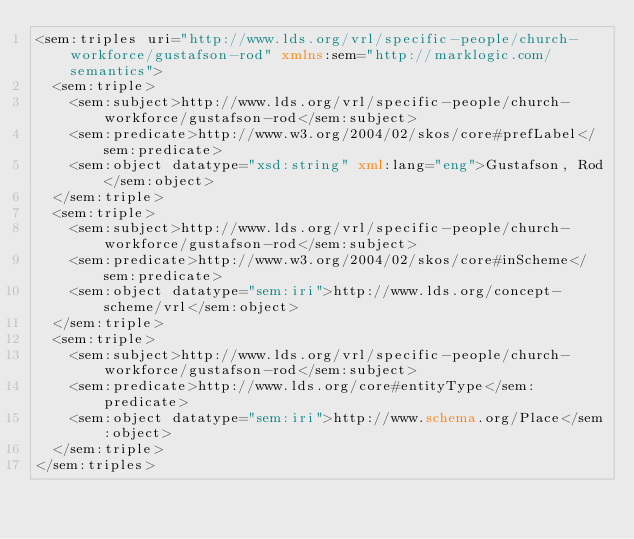Convert code to text. <code><loc_0><loc_0><loc_500><loc_500><_XML_><sem:triples uri="http://www.lds.org/vrl/specific-people/church-workforce/gustafson-rod" xmlns:sem="http://marklogic.com/semantics">
  <sem:triple>
    <sem:subject>http://www.lds.org/vrl/specific-people/church-workforce/gustafson-rod</sem:subject>
    <sem:predicate>http://www.w3.org/2004/02/skos/core#prefLabel</sem:predicate>
    <sem:object datatype="xsd:string" xml:lang="eng">Gustafson, Rod</sem:object>
  </sem:triple>
  <sem:triple>
    <sem:subject>http://www.lds.org/vrl/specific-people/church-workforce/gustafson-rod</sem:subject>
    <sem:predicate>http://www.w3.org/2004/02/skos/core#inScheme</sem:predicate>
    <sem:object datatype="sem:iri">http://www.lds.org/concept-scheme/vrl</sem:object>
  </sem:triple>
  <sem:triple>
    <sem:subject>http://www.lds.org/vrl/specific-people/church-workforce/gustafson-rod</sem:subject>
    <sem:predicate>http://www.lds.org/core#entityType</sem:predicate>
    <sem:object datatype="sem:iri">http://www.schema.org/Place</sem:object>
  </sem:triple>
</sem:triples>
</code> 